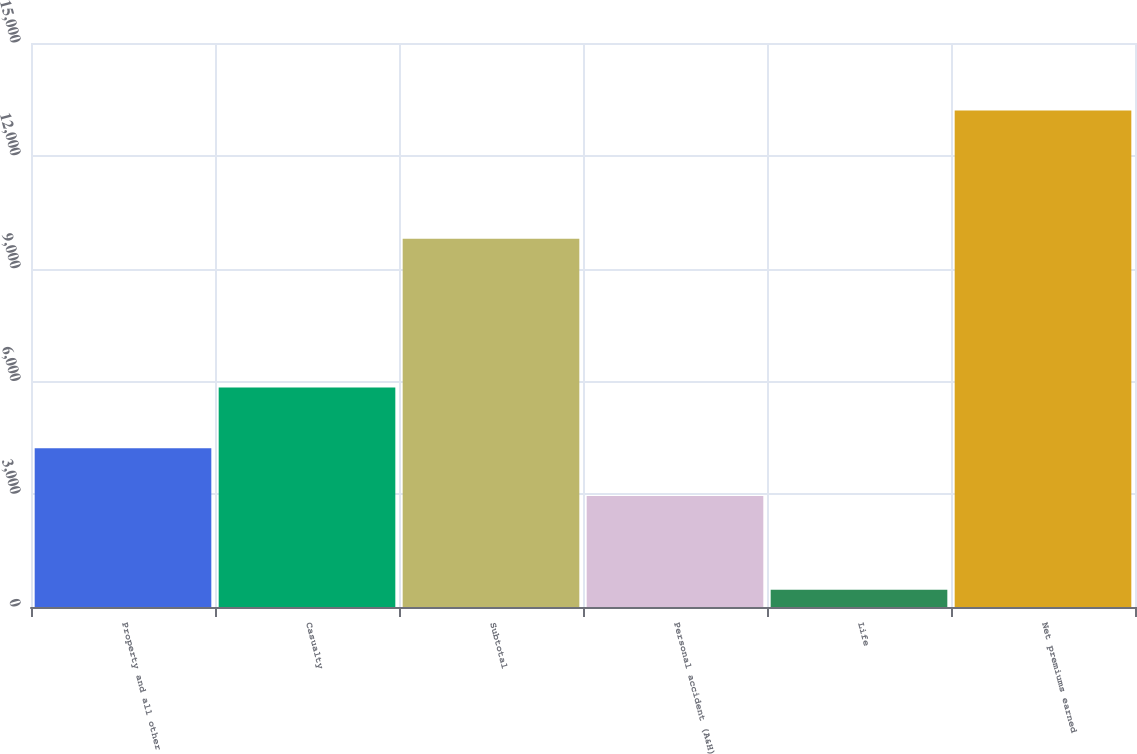<chart> <loc_0><loc_0><loc_500><loc_500><bar_chart><fcel>Property and all other<fcel>Casualty<fcel>Subtotal<fcel>Personal accident (A&H)<fcel>Life<fcel>Net premiums earned<nl><fcel>4223.1<fcel>5838<fcel>9792<fcel>2949<fcel>462<fcel>13203<nl></chart> 